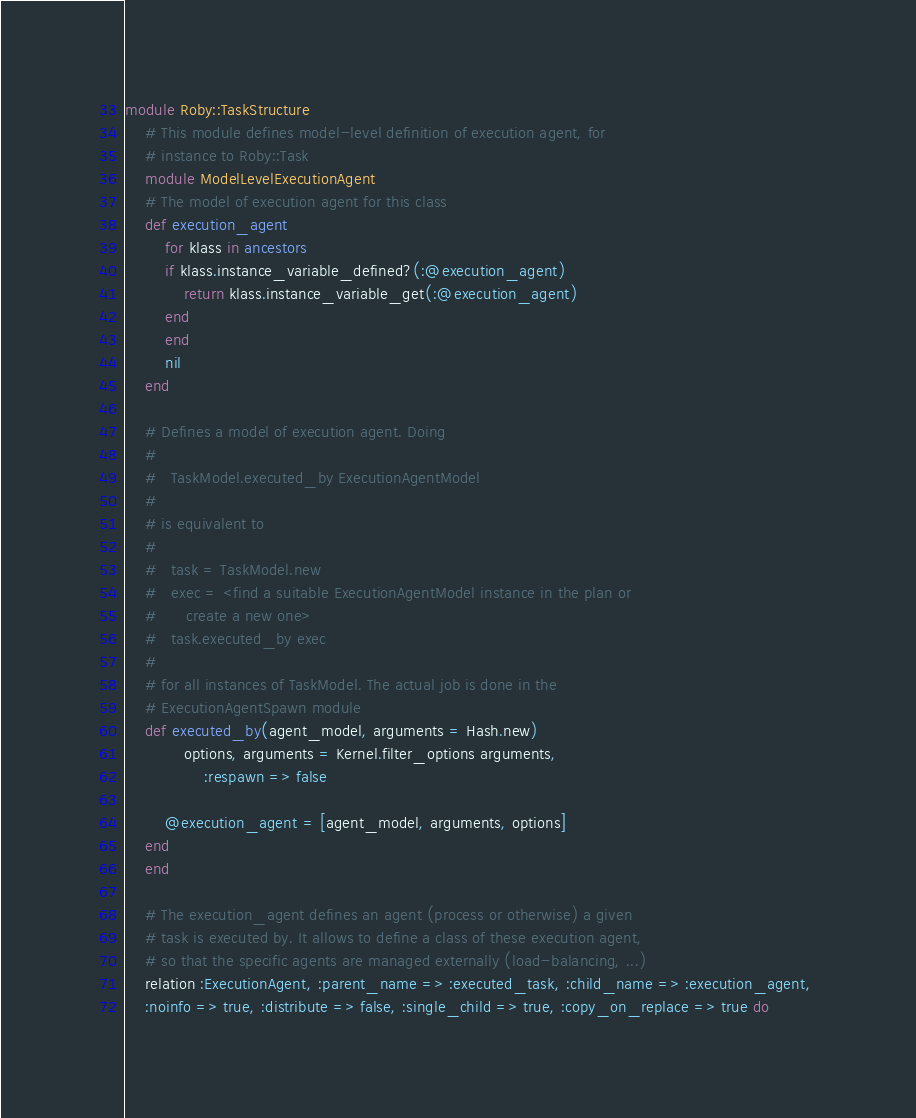<code> <loc_0><loc_0><loc_500><loc_500><_Ruby_>module Roby::TaskStructure
    # This module defines model-level definition of execution agent, for
    # instance to Roby::Task
    module ModelLevelExecutionAgent
	# The model of execution agent for this class
	def execution_agent
	    for klass in ancestors
		if klass.instance_variable_defined?(:@execution_agent)
		    return klass.instance_variable_get(:@execution_agent)
		end
	    end
	    nil
	end

	# Defines a model of execution agent. Doing
	#
	#   TaskModel.executed_by ExecutionAgentModel
	#
	# is equivalent to
	#
	#   task = TaskModel.new
	#   exec = <find a suitable ExecutionAgentModel instance in the plan or
	#	   create a new one>
	#   task.executed_by exec
	#   
	# for all instances of TaskModel. The actual job is done in the
	# ExecutionAgentSpawn module
	def executed_by(agent_model, arguments = Hash.new)
            options, arguments = Kernel.filter_options arguments,
                :respawn => false

	    @execution_agent = [agent_model, arguments, options]
	end
    end

    # The execution_agent defines an agent (process or otherwise) a given
    # task is executed by. It allows to define a class of these execution agent,
    # so that the specific agents are managed externally (load-balancing, ...)
    relation :ExecutionAgent, :parent_name => :executed_task, :child_name => :execution_agent, 
	:noinfo => true, :distribute => false, :single_child => true, :copy_on_replace => true do
</code> 